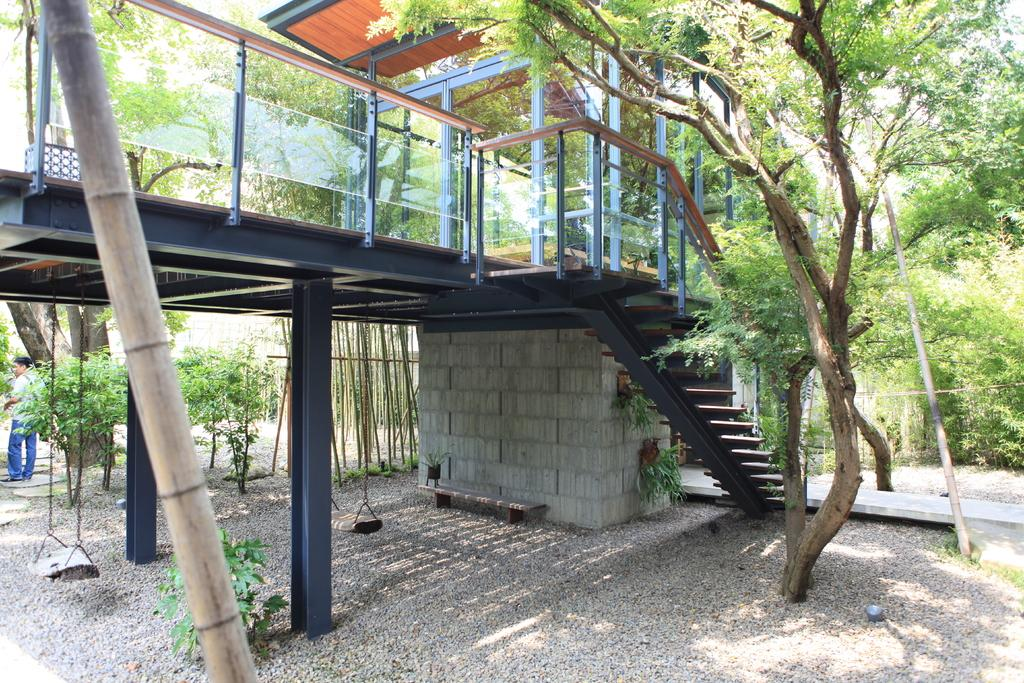What type of structure is in the image? There is a bridge in the image. What architectural feature can be seen in the image? There are stairs in the image. Can you describe the person in the image? There is a person standing to the left in the image. What objects are made of glass in the image? Glasses are visible in the image. What material are the poles in the image made of? Metal poles are present in the image. What can be seen in the background of the image? There are many trees in the background of the image. What type of food is being prepared on the plough in the image? There is no plough or food preparation visible in the image. How does the acoustics of the bridge affect the sound in the image? The image does not provide information about the acoustics of the bridge or any sound effects. 